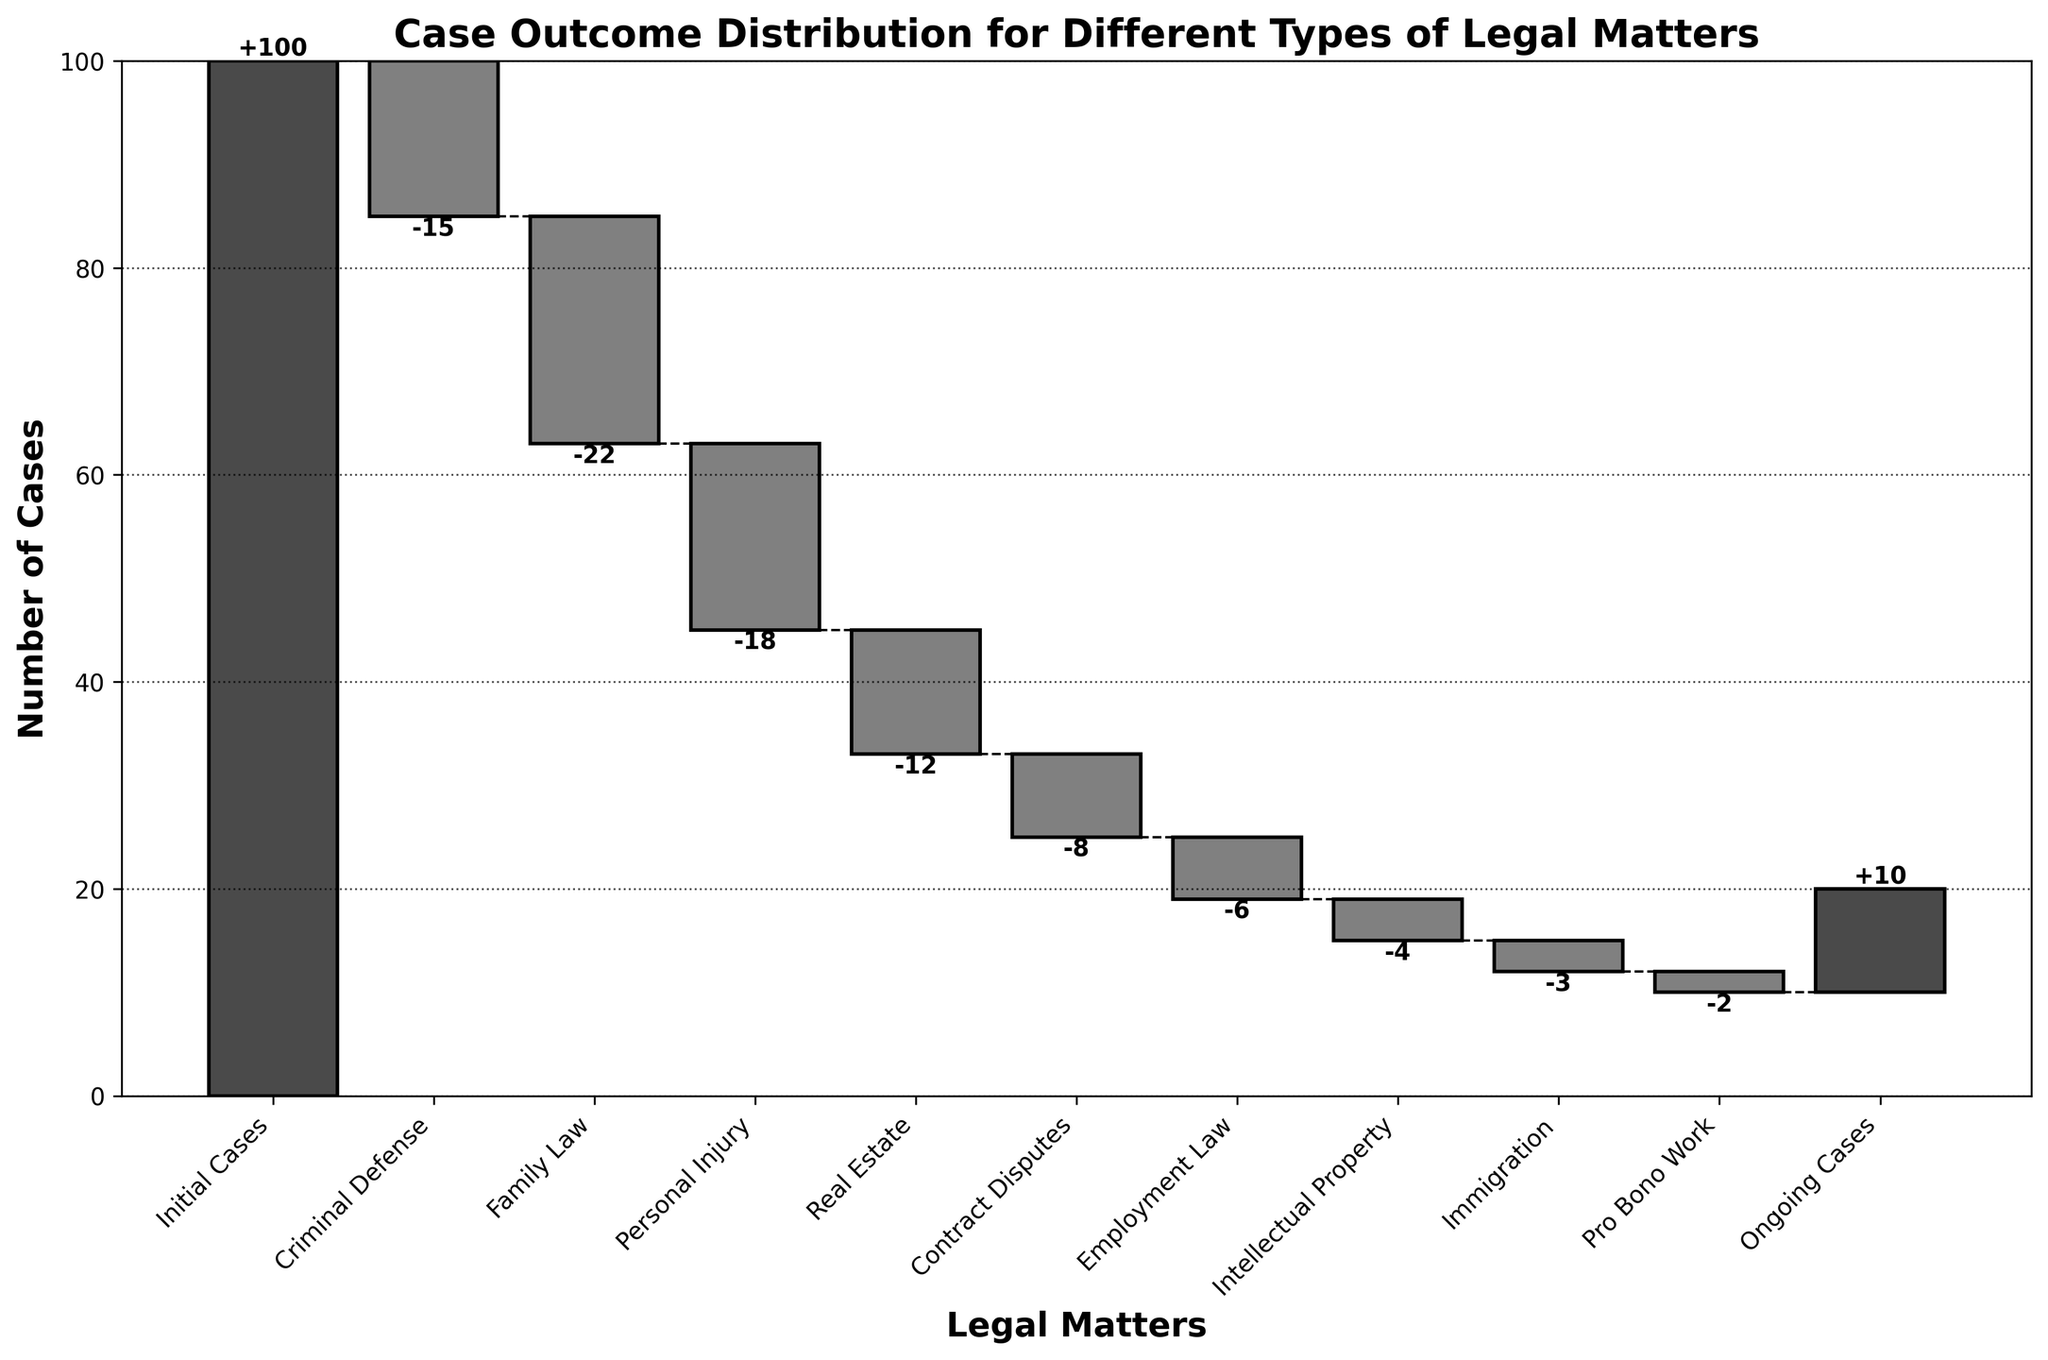What's the title of the figure? The title is displayed at the top of the figure and typically summarizes the content or purpose of the graph for the viewer.
Answer: Case Outcome Distribution for Different Types of Legal Matters What's the label on the y-axis? The y-axis label is found vertically along the y-axis and indicates what the plotted values represent.
Answer: Number of Cases How many categories are there in total? Count the number of different categories listed on the x-axis.
Answer: 10 Which category contributed the most negatively to the total number of cases? Compare the negative values for each category and see which one has the largest absolute value.
Answer: Family Law What is the net change in the total number of cases from 'Initial Cases' to 'Ongoing Cases'? Calculate the sum of all the values: -15 - 22 -18 - 12 - 8 - 6 - 4 - 3 - 2 + 10 = -80. Combine this with the initial value: 100 + (-80) = 20.
Answer: -80 How does the number of 'Criminal Defense' cases compare to the number of 'Employment Law' cases? Compare the respective values for 'Criminal Defense' (-15) and 'Employment Law' (-6).
Answer: Criminal Defense cases are fewer than Employment Law cases by absolute value What's the difference in the number of cases handled between 'Real Estate' and 'Personal Injury'? Subtract the number of cases in 'Real Estate' (-12) from 'Personal Injury' (-18): -18 - (-12) = -6.
Answer: 6 In which categories were there four or fewer cases? Identify categories with values greater than or equal to -4 ('Intellectual Property' and 'Immigration').
Answer: Intellectual Property and Immigration Which category immediately follows 'Family Law'? Look at the x-axis labels to find the category that comes right after 'Family Law'.
Answer: Personal Injury 